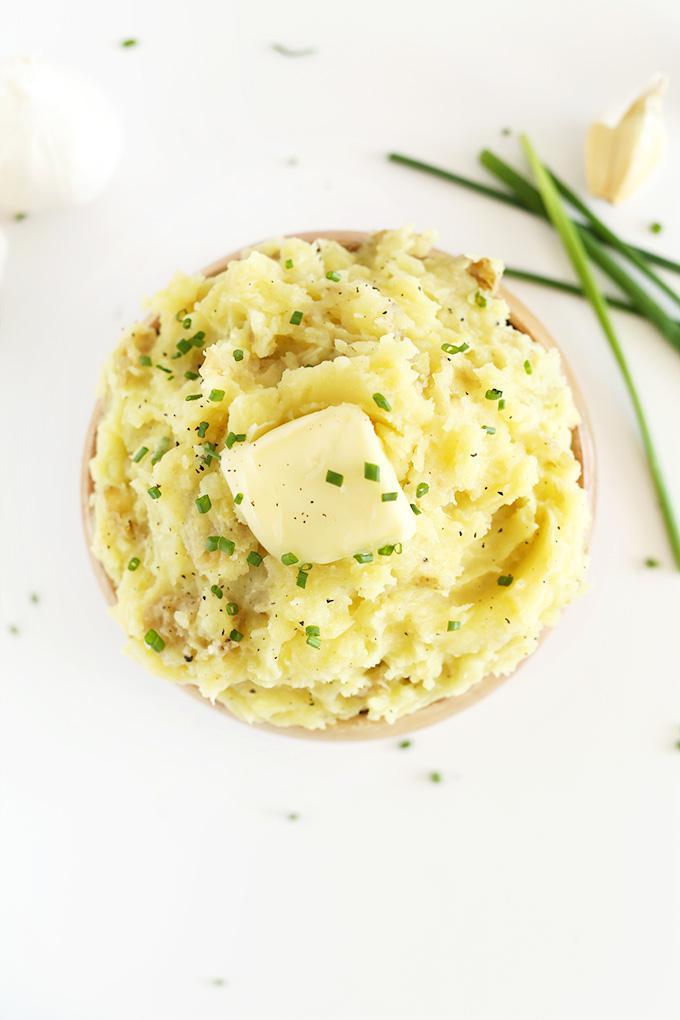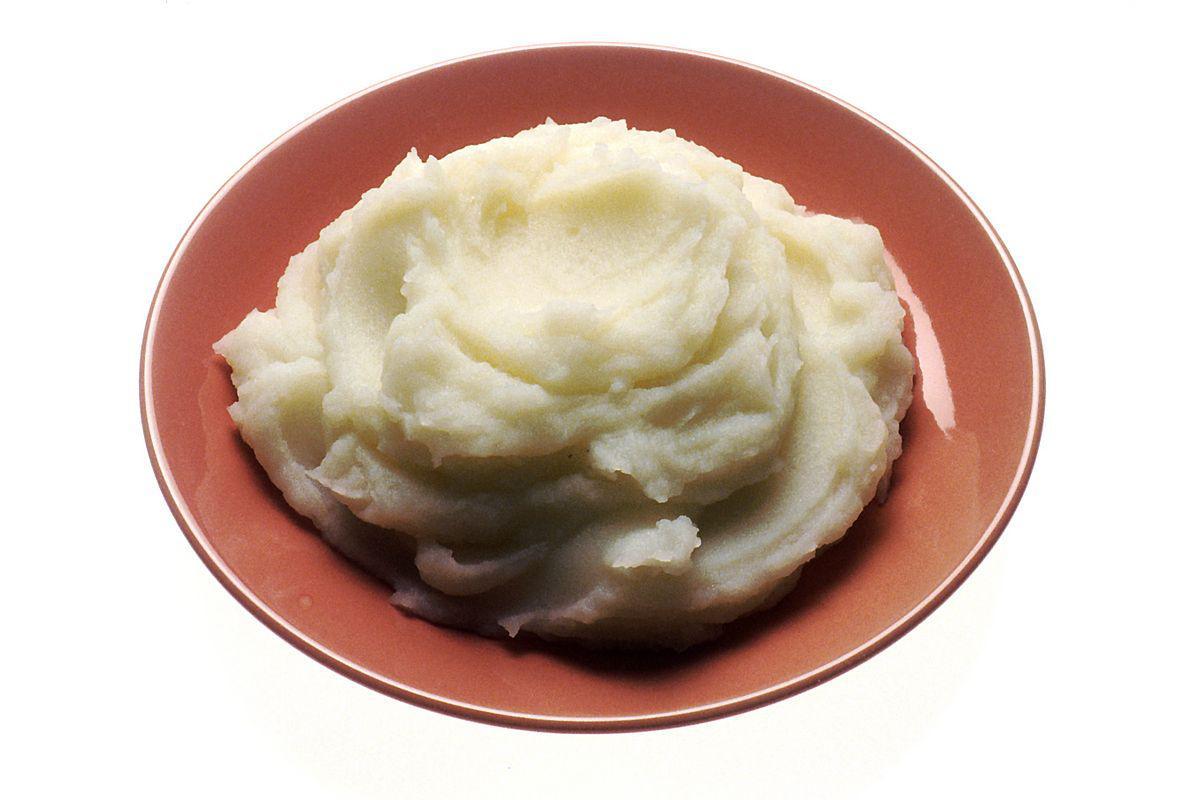The first image is the image on the left, the second image is the image on the right. For the images displayed, is the sentence "A white bowl is holding the food in the image on the right." factually correct? Answer yes or no. No. 